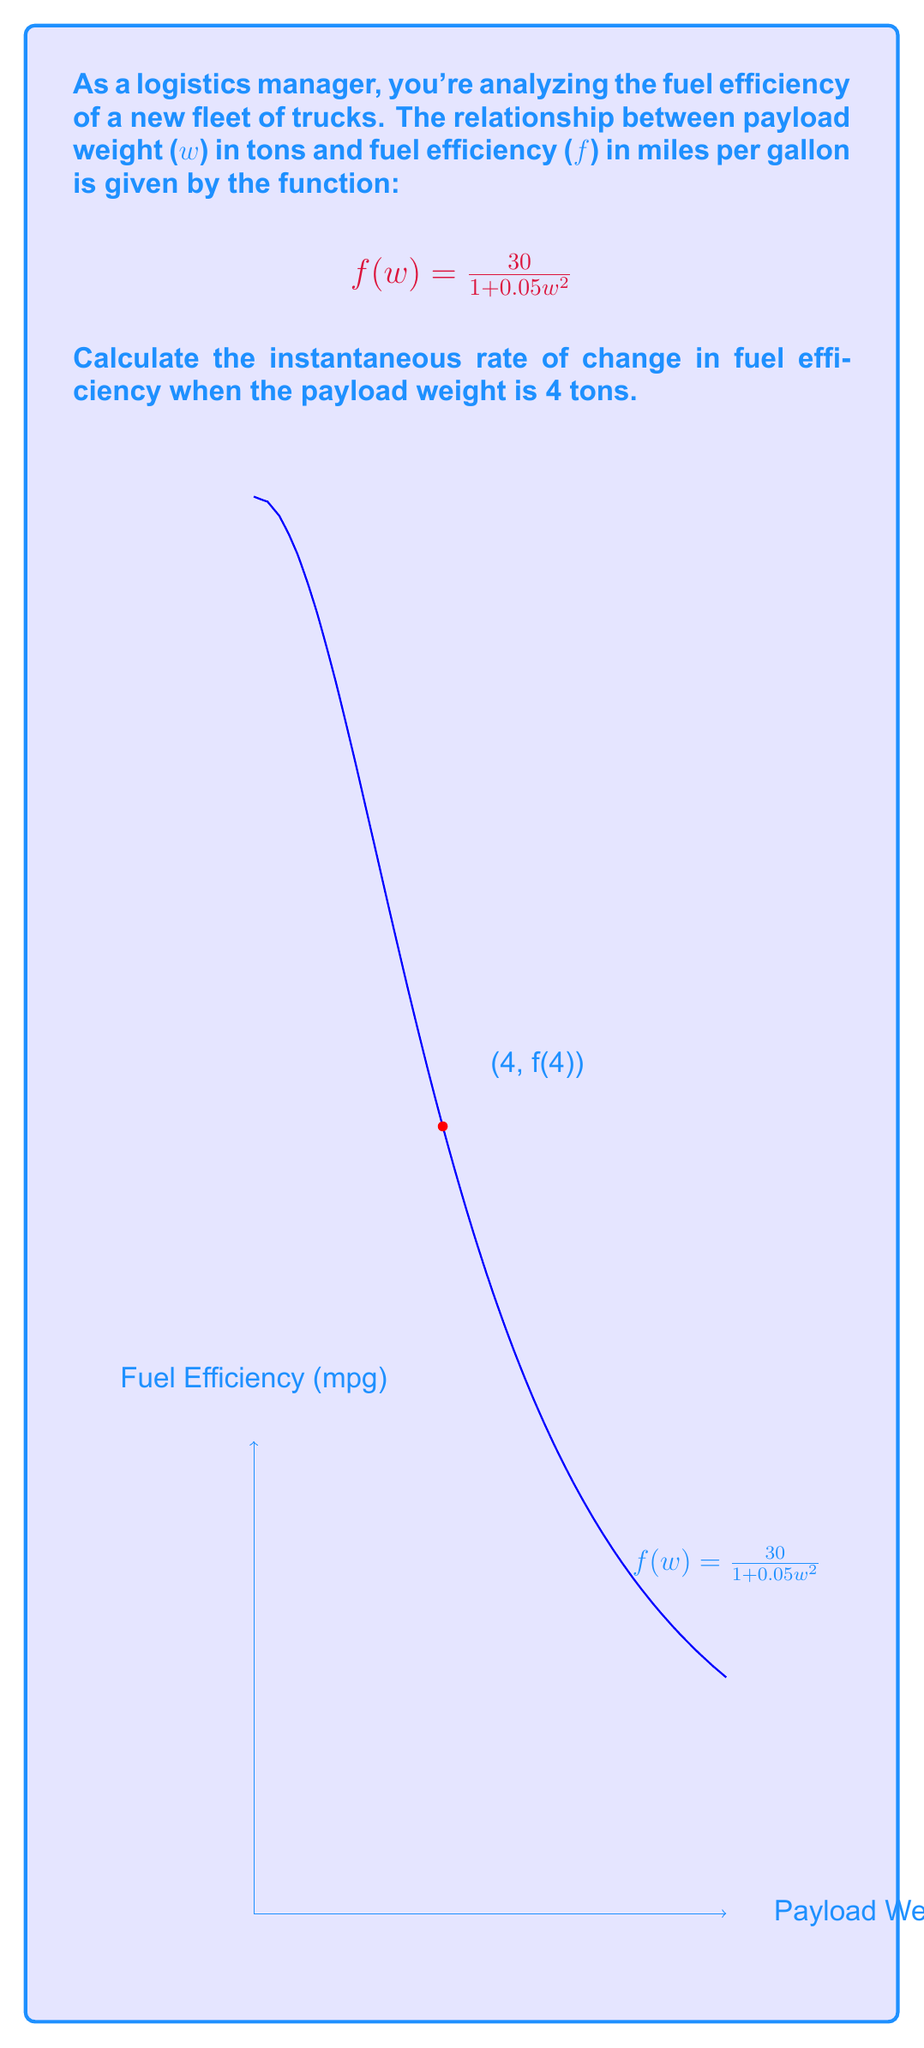Show me your answer to this math problem. To find the instantaneous rate of change, we need to calculate the derivative of the function $f(w)$ and evaluate it at $w = 4$.

Step 1: Find the derivative of $f(w)$ using the quotient rule.
$$f'(w) = \frac{d}{dw}\left(\frac{30}{1 + 0.05w^2}\right)$$
$$f'(w) = \frac{(1 + 0.05w^2) \cdot \frac{d}{dw}(30) - 30 \cdot \frac{d}{dw}(1 + 0.05w^2)}{(1 + 0.05w^2)^2}$$

Step 2: Simplify the derivative.
$$f'(w) = \frac{0 - 30 \cdot (0.1w)}{(1 + 0.05w^2)^2}$$
$$f'(w) = -\frac{3w}{(1 + 0.05w^2)^2}$$

Step 3: Evaluate $f'(w)$ at $w = 4$.
$$f'(4) = -\frac{3(4)}{(1 + 0.05(4)^2)^2}$$
$$f'(4) = -\frac{12}{(1 + 0.05(16))^2}$$
$$f'(4) = -\frac{12}{(1.8)^2}$$
$$f'(4) = -\frac{12}{3.24}$$
$$f'(4) = -3.7037...$$

The negative value indicates that the fuel efficiency is decreasing as the payload weight increases.
Answer: $-3.7037$ mpg/ton 